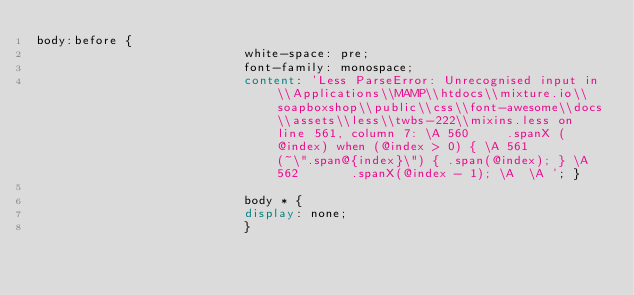Convert code to text. <code><loc_0><loc_0><loc_500><loc_500><_CSS_>body:before { 
                            white-space: pre; 
                            font-family: monospace; 
                            content: 'Less ParseError: Unrecognised input in \\Applications\\MAMP\\htdocs\\mixture.io\\soapboxshop\\public\\css\\font-awesome\\docs\\assets\\less\\twbs-222\\mixins.less on line 561, column 7: \A 560     .spanX (@index) when (@index > 0) { \A 561       (~\".span@{index}\") { .span(@index); } \A 562       .spanX(@index - 1); \A  \A '; } 
                            
                            body * { 
                            display: none; 
                            } </code> 